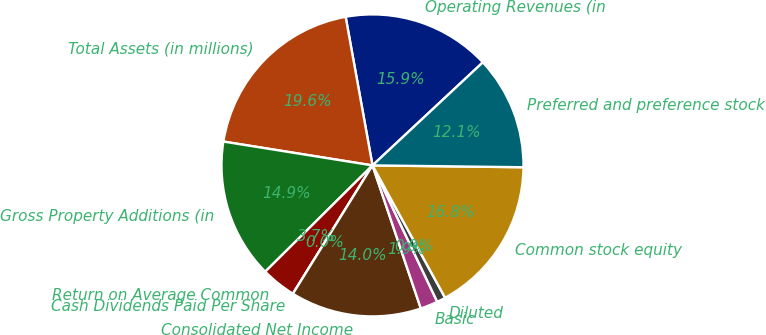Convert chart to OTSL. <chart><loc_0><loc_0><loc_500><loc_500><pie_chart><fcel>Operating Revenues (in<fcel>Total Assets (in millions)<fcel>Gross Property Additions (in<fcel>Return on Average Common<fcel>Cash Dividends Paid Per Share<fcel>Consolidated Net Income<fcel>Basic<fcel>Diluted<fcel>Common stock equity<fcel>Preferred and preference stock<nl><fcel>15.89%<fcel>19.63%<fcel>14.95%<fcel>3.74%<fcel>0.0%<fcel>14.02%<fcel>1.87%<fcel>0.93%<fcel>16.82%<fcel>12.15%<nl></chart> 